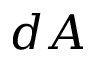Convert formula to latex. <formula><loc_0><loc_0><loc_500><loc_500>d A</formula> 